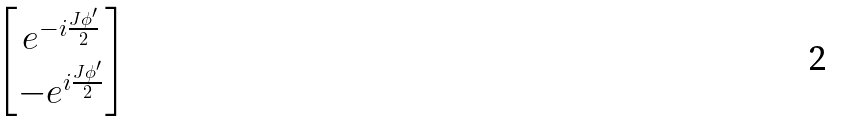<formula> <loc_0><loc_0><loc_500><loc_500>\begin{bmatrix} e ^ { - i \frac { J \phi ^ { \prime } } { 2 } } \\ - e ^ { i \frac { J \phi ^ { \prime } } { 2 } } \end{bmatrix}</formula> 